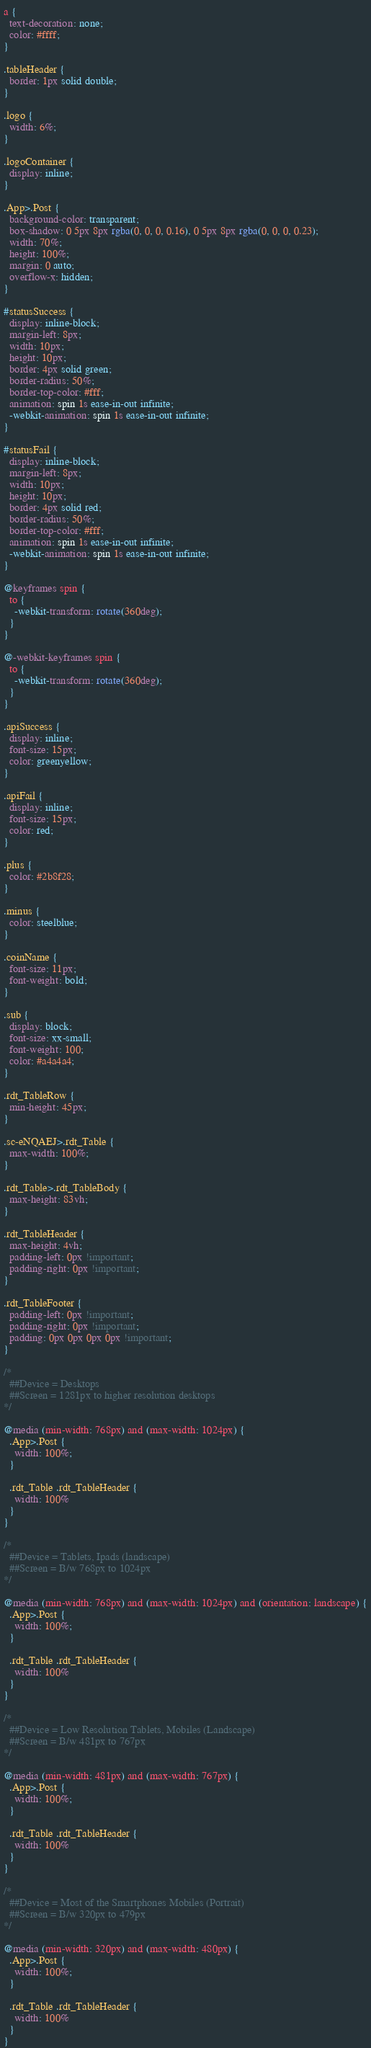<code> <loc_0><loc_0><loc_500><loc_500><_CSS_>a {
  text-decoration: none;
  color: #ffff;
}

.tableHeader {
  border: 1px solid double;
}

.logo {
  width: 6%;
}

.logoContainer {
  display: inline;
}

.App>.Post {
  background-color: transparent;
  box-shadow: 0 5px 8px rgba(0, 0, 0, 0.16), 0 5px 8px rgba(0, 0, 0, 0.23);
  width: 70%;
  height: 100%;
  margin: 0 auto;
  overflow-x: hidden;
}

#statusSuccess {
  display: inline-block;
  margin-left: 8px;
  width: 10px;
  height: 10px;
  border: 4px solid green;
  border-radius: 50%;
  border-top-color: #fff;
  animation: spin 1s ease-in-out infinite;
  -webkit-animation: spin 1s ease-in-out infinite;
}

#statusFail {
  display: inline-block;
  margin-left: 8px;
  width: 10px;
  height: 10px;
  border: 4px solid red;
  border-radius: 50%;
  border-top-color: #fff;
  animation: spin 1s ease-in-out infinite;
  -webkit-animation: spin 1s ease-in-out infinite;
}

@keyframes spin {
  to {
    -webkit-transform: rotate(360deg);
  }
}

@-webkit-keyframes spin {
  to {
    -webkit-transform: rotate(360deg);
  }
}

.apiSuccess {
  display: inline;
  font-size: 15px;
  color: greenyellow;
}

.apiFail {
  display: inline;
  font-size: 15px;
  color: red;
}

.plus {
  color: #2b8f28;
}

.minus {
  color: steelblue;
}

.coinName {
  font-size: 11px;
  font-weight: bold;
}

.sub {
  display: block;
  font-size: xx-small;
  font-weight: 100;
  color: #a4a4a4;
}

.rdt_TableRow {
  min-height: 45px;
}

.sc-eNQAEJ>.rdt_Table {
  max-width: 100%;
}

.rdt_Table>.rdt_TableBody {
  max-height: 83vh;
}

.rdt_TableHeader {
  max-height: 4vh;
  padding-left: 0px !important;
  padding-right: 0px !important;
}

.rdt_TableFooter {
  padding-left: 0px !important;
  padding-right: 0px !important;
  padding: 0px 0px 0px 0px !important;
}

/*
  ##Device = Desktops
  ##Screen = 1281px to higher resolution desktops
*/

@media (min-width: 768px) and (max-width: 1024px) {
  .App>.Post {
    width: 100%;
  }

  .rdt_Table .rdt_TableHeader {
    width: 100%
  }
}

/*
  ##Device = Tablets, Ipads (landscape)
  ##Screen = B/w 768px to 1024px
*/

@media (min-width: 768px) and (max-width: 1024px) and (orientation: landscape) {
  .App>.Post {
    width: 100%;
  }

  .rdt_Table .rdt_TableHeader {
    width: 100%
  }
}

/*
  ##Device = Low Resolution Tablets, Mobiles (Landscape)
  ##Screen = B/w 481px to 767px
*/

@media (min-width: 481px) and (max-width: 767px) {
  .App>.Post {
    width: 100%;
  }

  .rdt_Table .rdt_TableHeader {
    width: 100%
  }
}

/*
  ##Device = Most of the Smartphones Mobiles (Portrait)
  ##Screen = B/w 320px to 479px
*/

@media (min-width: 320px) and (max-width: 480px) {
  .App>.Post {
    width: 100%;
  }

  .rdt_Table .rdt_TableHeader {
    width: 100%
  }
}</code> 